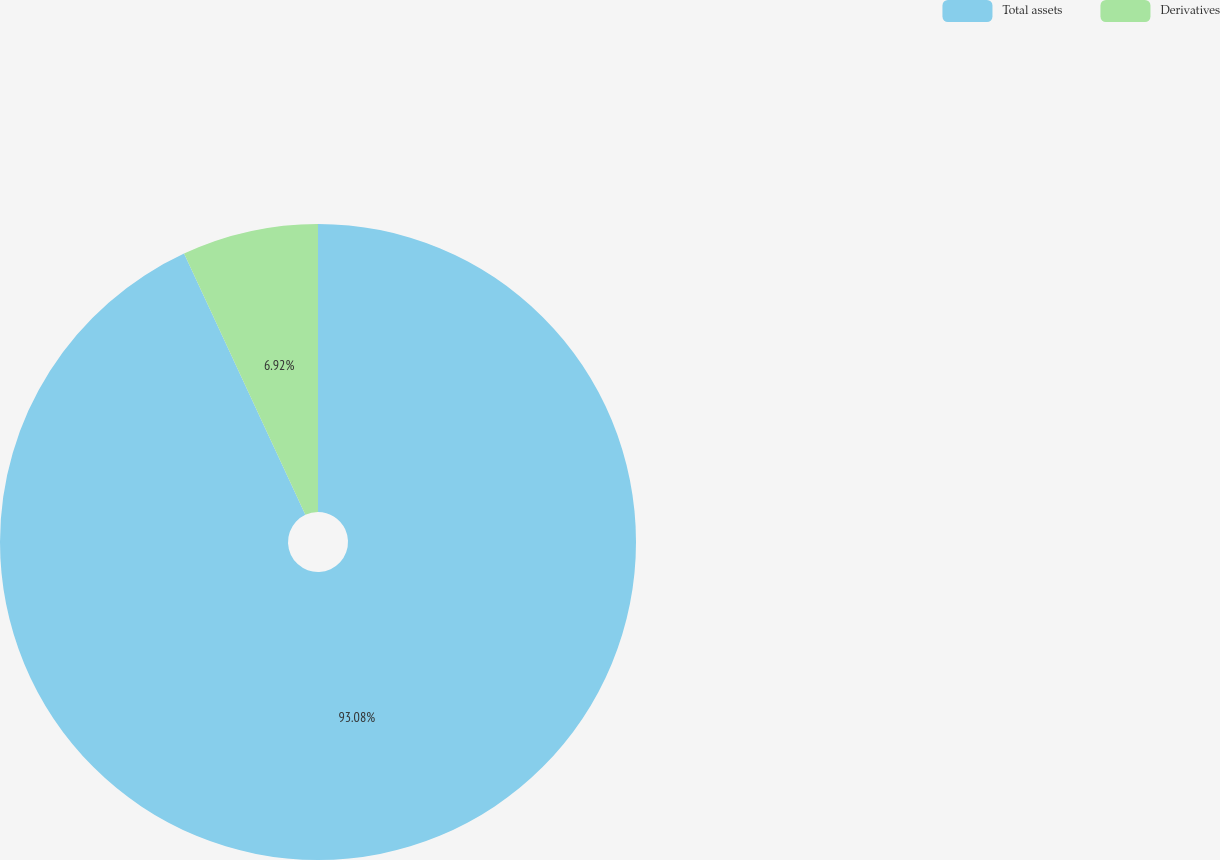<chart> <loc_0><loc_0><loc_500><loc_500><pie_chart><fcel>Total assets<fcel>Derivatives<nl><fcel>93.08%<fcel>6.92%<nl></chart> 